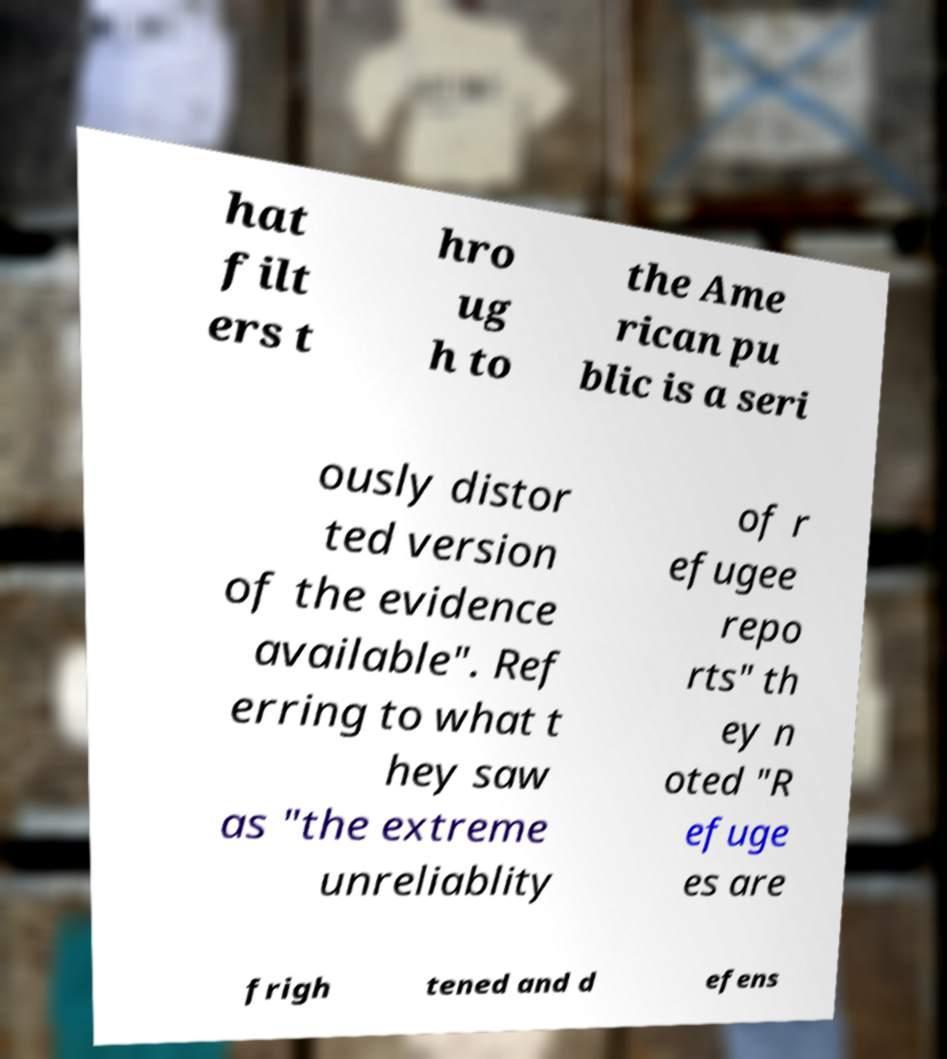Could you extract and type out the text from this image? hat filt ers t hro ug h to the Ame rican pu blic is a seri ously distor ted version of the evidence available". Ref erring to what t hey saw as "the extreme unreliablity of r efugee repo rts" th ey n oted "R efuge es are frigh tened and d efens 